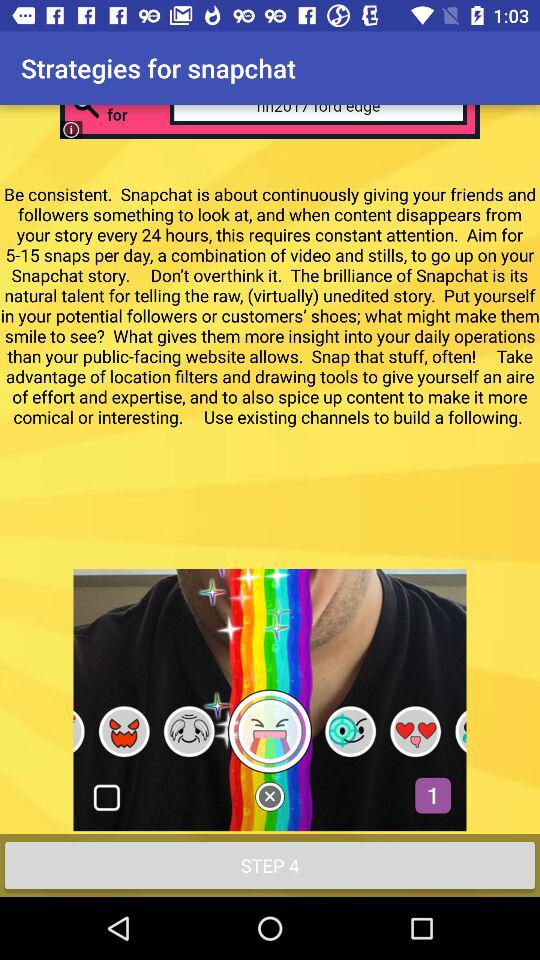How many steps are there in the process?
Answer the question using a single word or phrase. 4 